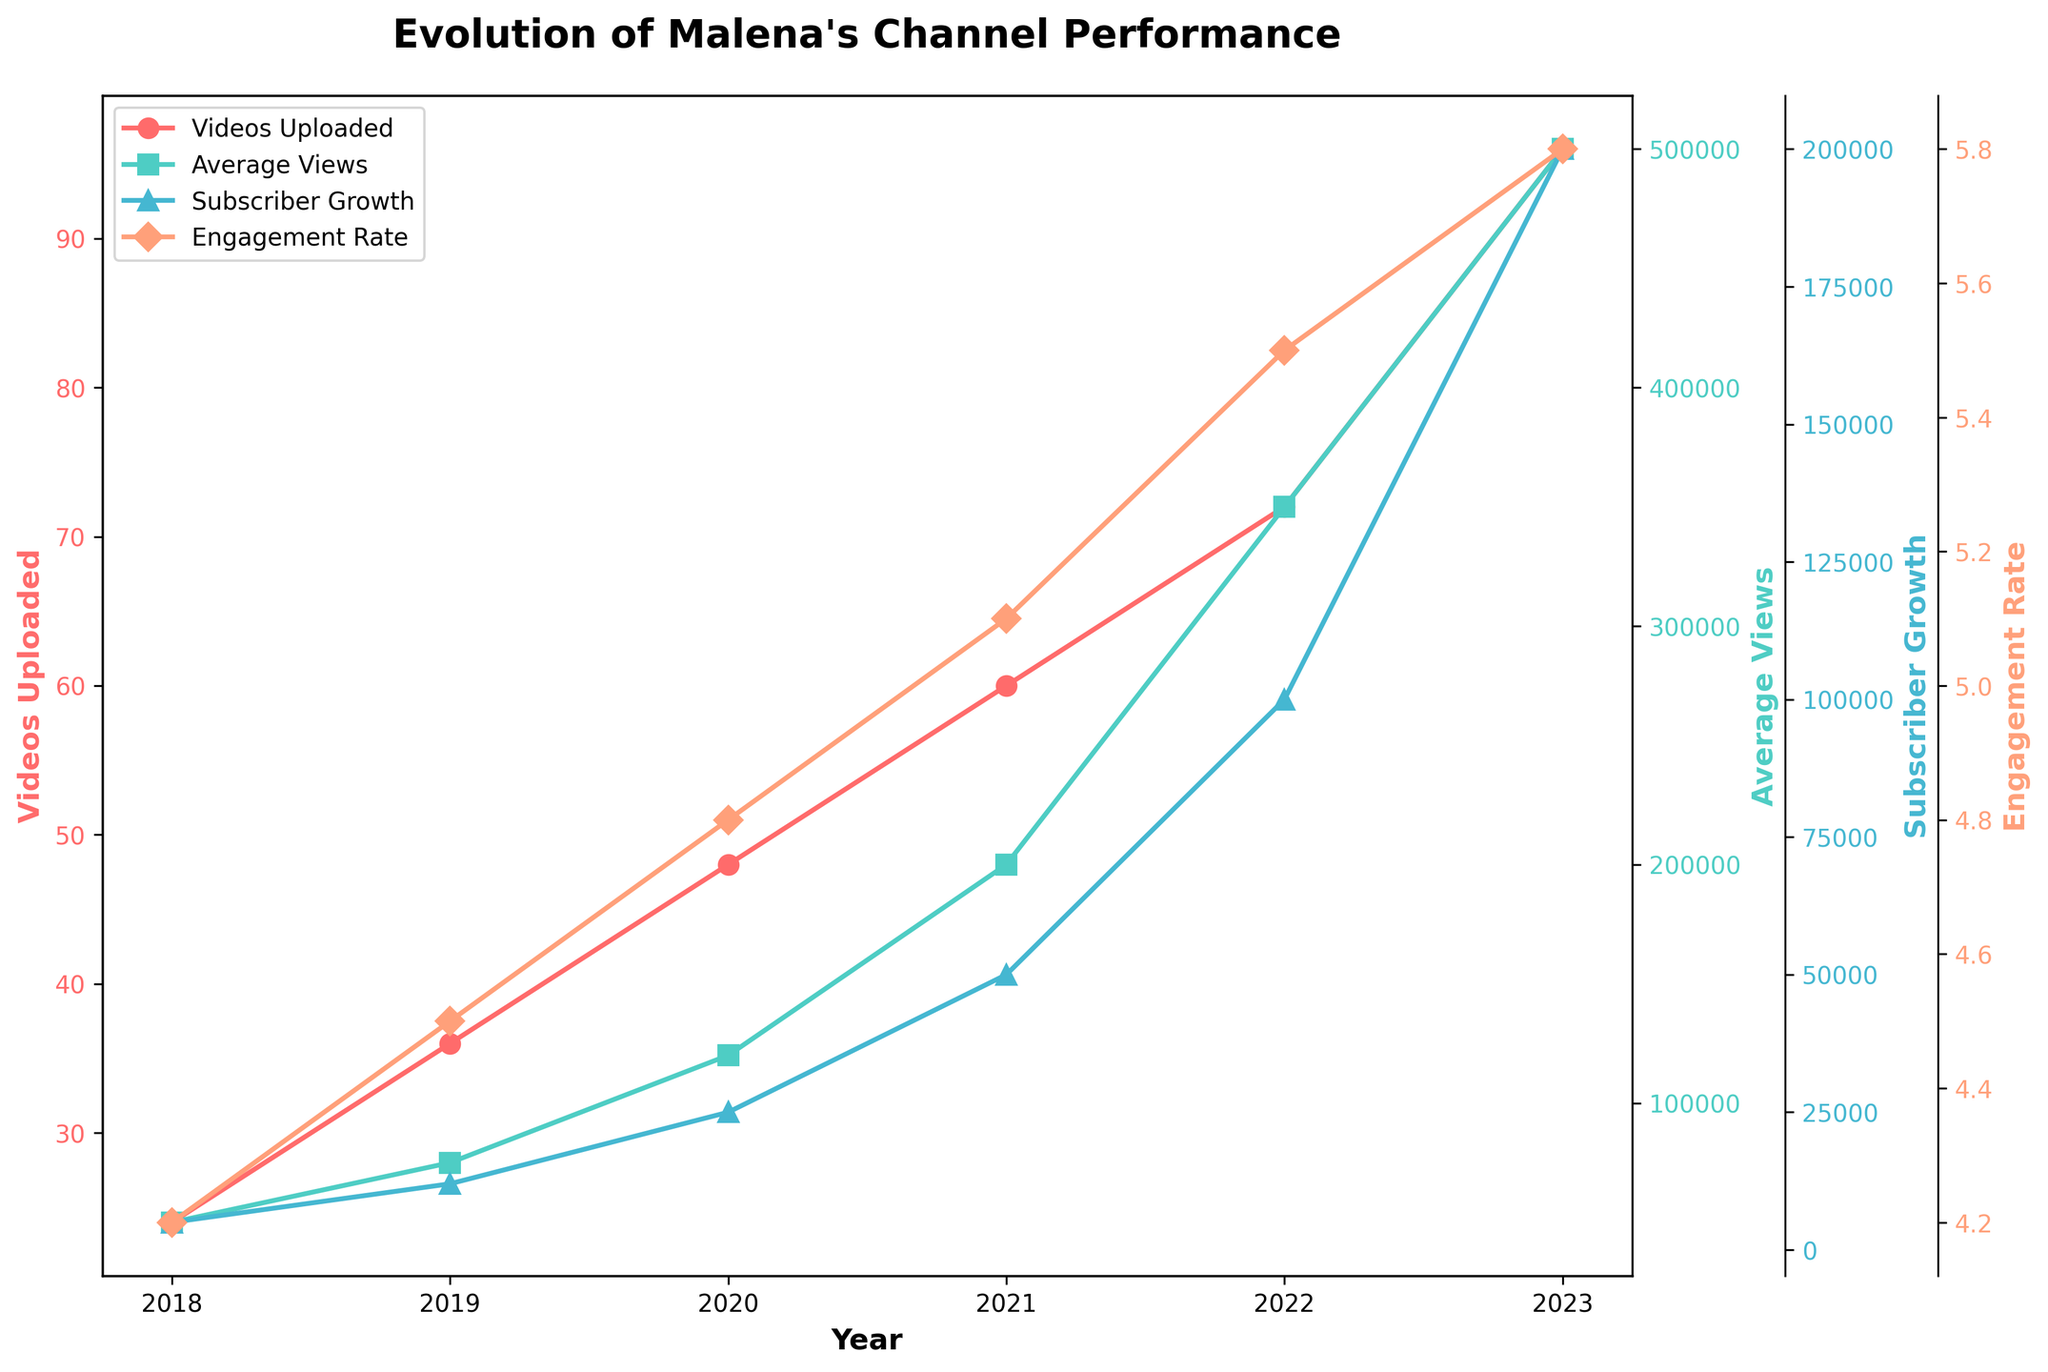How many videos did Malena upload in 2020, and how does it compare to the number of videos uploaded in 2018? Malena uploaded 48 videos in 2020 and 24 videos in 2018. To compare, we subtract the number of videos uploaded in 2018 from those in 2020: 48 - 24.
Answer: 24 more videos in 2020 than in 2018 What is the general trend of average views from 2018 to 2023? We observe that the average views increase consistently each year: 50,000 in 2018, 75,000 in 2019, 120,000 in 2020, 200,000 in 2021, 350,000 in 2022, and 500,000 in 2023.
Answer: Increasing Trend Which year saw the highest subscriber growth? By visual examination, 2023 displays the highest subscriber growth with 200,000 new subscribers.
Answer: 2023 Between 2019 and 2021, what is the increase in engagement rate? The engagement rate in 2019 was 4.5, and in 2021 it was 5.1. The increase can be calculated as 5.1 - 4.5.
Answer: 0.6 Compare the videos uploaded and the average views in 2023. Which metric had a higher absolute value? In 2023, the video uploads were 96, and the average views were 500,000. Comparing these two values, the average views had a higher absolute value.
Answer: Average Views What is the proportional increase in average views from 2020 to 2022? The average views in 2020 were 120,000 and in 2022 were 350,000. The proportional increase is calculated by (350,000 - 120,000) / 120,000.
Answer: Approximately 1.92 How did the engagement rate in 2021 compare to that in 2023? In 2021, the engagement rate was 5.1, and in 2023 it was 5.8. To find the difference, calculate 5.8 - 5.1.
Answer: 0.7 higher in 2023 What was the combined subscriber growth for the years 2020 and 2021? The subscriber growth in 2020 was 25,000, and in 2021 it was 50,000. To find the combined growth, add these two numbers: 25,000 + 50,000.
Answer: 75,000 Is there a year where both the number of videos uploaded and the engagement rate increased compared to the previous year? Upon inspection, from 2021 to 2022, both the number of videos uploaded (from 60 to 72) and the engagement rate (from 5.1 to 5.5) increased.
Answer: Yes, 2022 From 2018 to 2020, what is the overall increase in videos uploaded? Malena uploaded 24 videos in 2018 and 48 videos in 2020. The overall increase is calculated as 48 - 24.
Answer: 24 more videos 